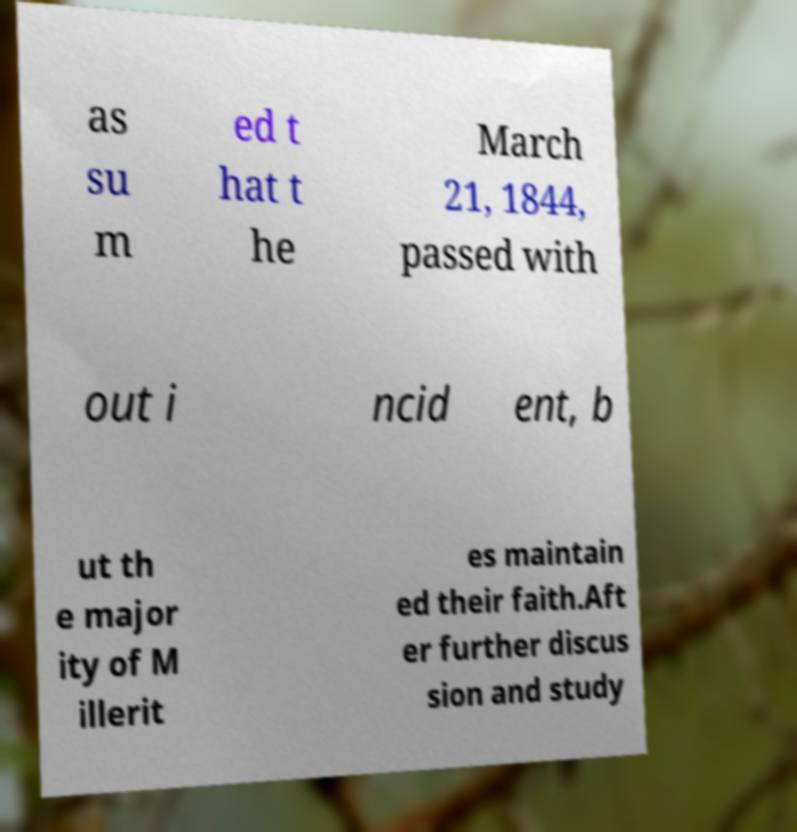For documentation purposes, I need the text within this image transcribed. Could you provide that? as su m ed t hat t he March 21, 1844, passed with out i ncid ent, b ut th e major ity of M illerit es maintain ed their faith.Aft er further discus sion and study 